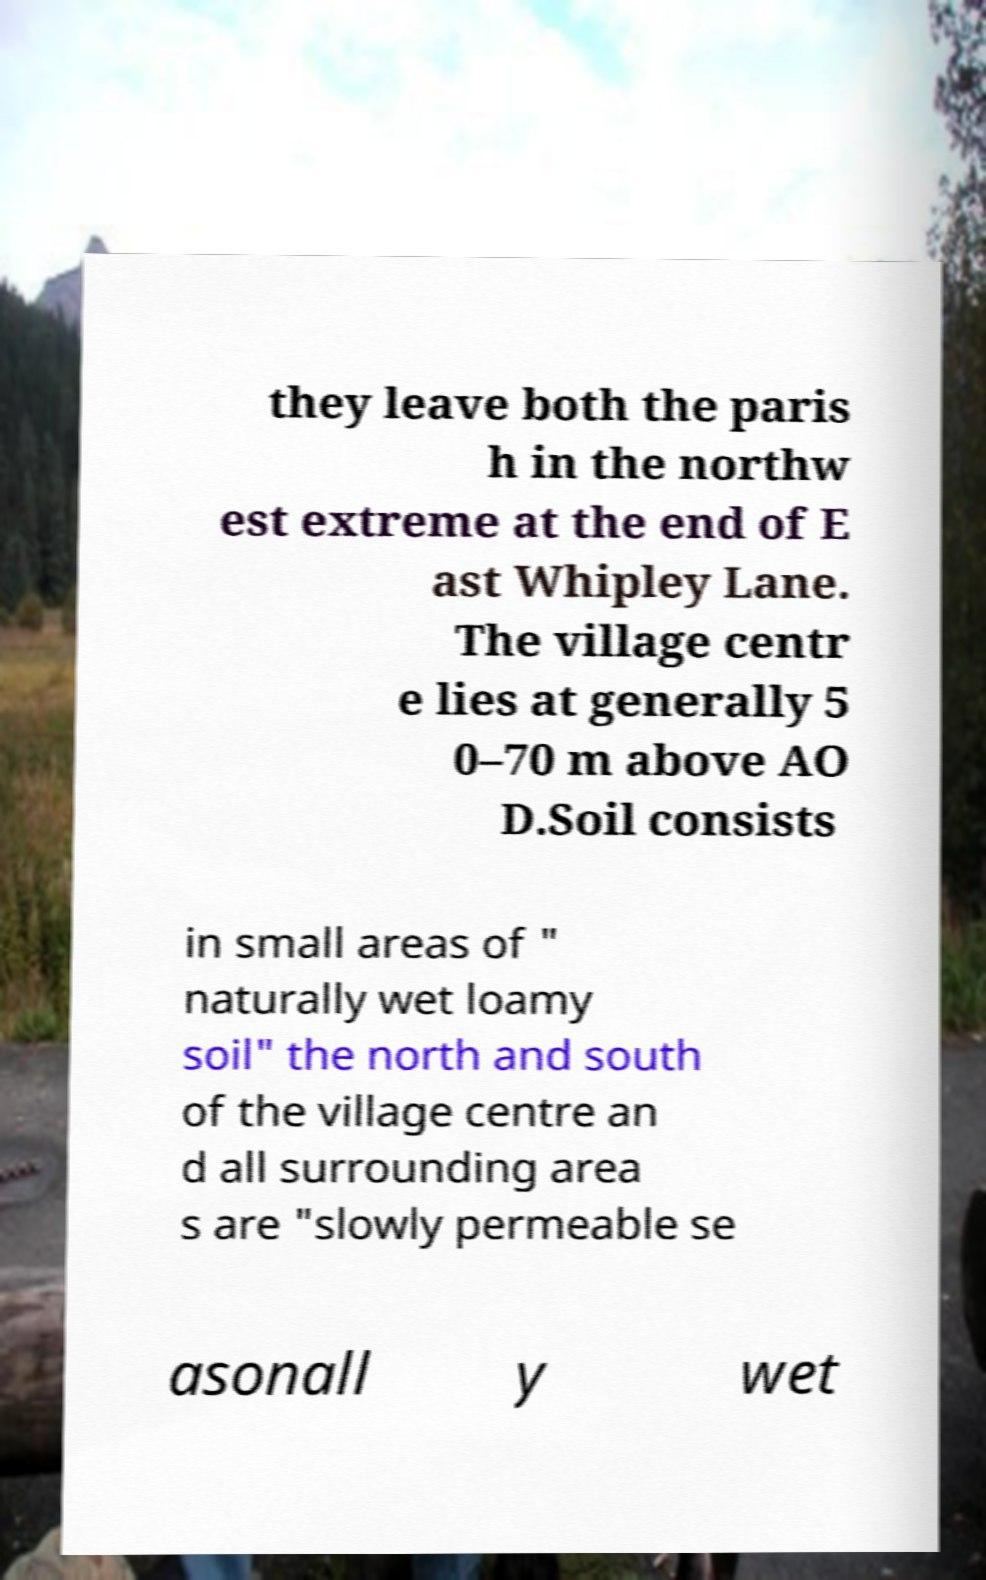Please read and relay the text visible in this image. What does it say? they leave both the paris h in the northw est extreme at the end of E ast Whipley Lane. The village centr e lies at generally 5 0–70 m above AO D.Soil consists in small areas of " naturally wet loamy soil" the north and south of the village centre an d all surrounding area s are "slowly permeable se asonall y wet 